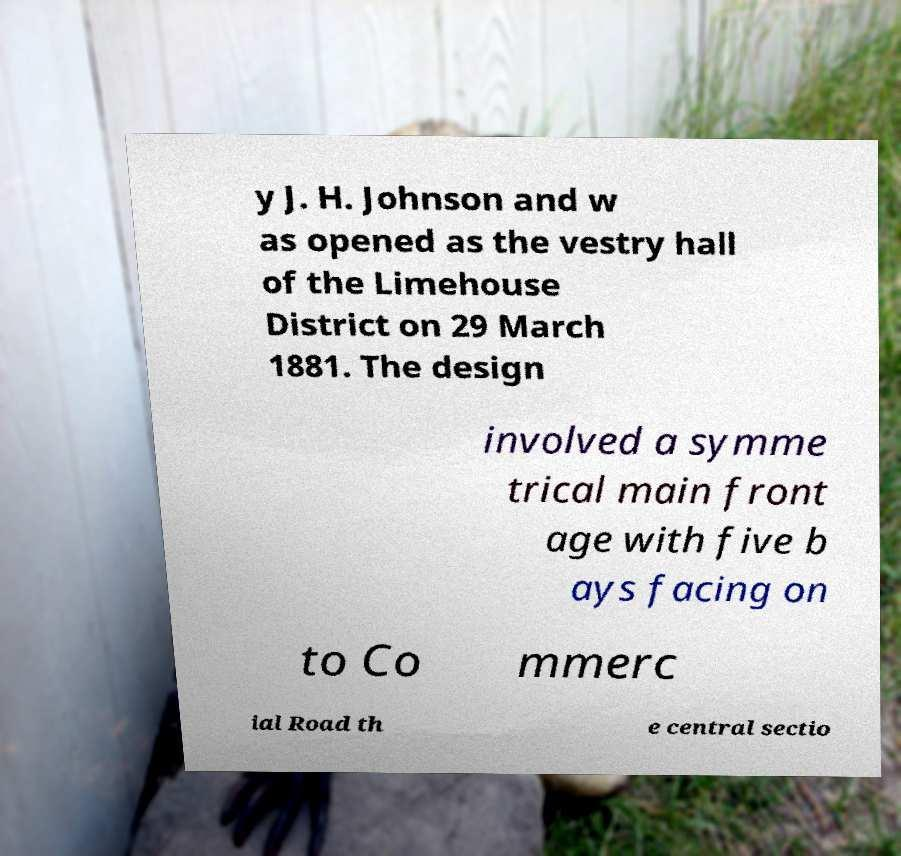Can you read and provide the text displayed in the image?This photo seems to have some interesting text. Can you extract and type it out for me? y J. H. Johnson and w as opened as the vestry hall of the Limehouse District on 29 March 1881. The design involved a symme trical main front age with five b ays facing on to Co mmerc ial Road th e central sectio 